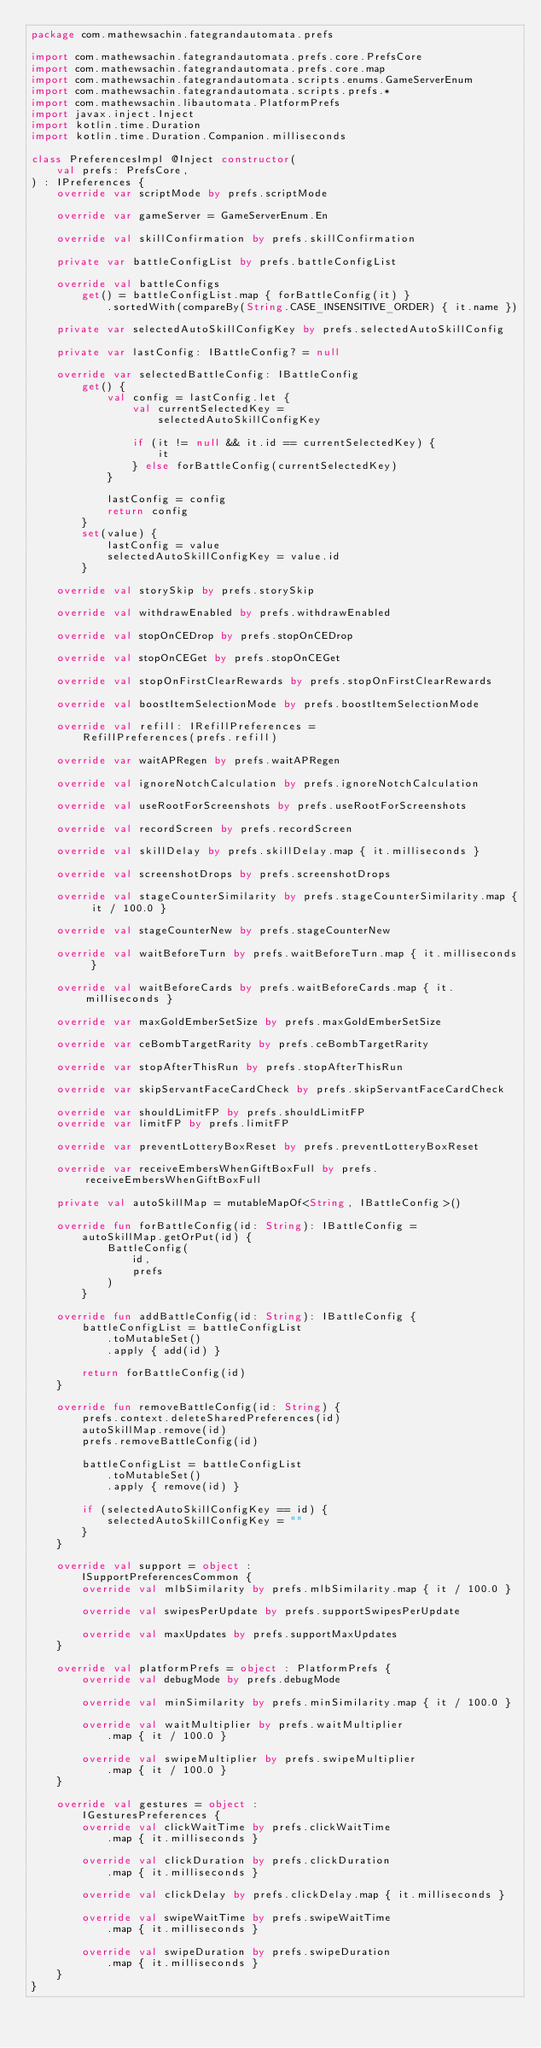Convert code to text. <code><loc_0><loc_0><loc_500><loc_500><_Kotlin_>package com.mathewsachin.fategrandautomata.prefs

import com.mathewsachin.fategrandautomata.prefs.core.PrefsCore
import com.mathewsachin.fategrandautomata.prefs.core.map
import com.mathewsachin.fategrandautomata.scripts.enums.GameServerEnum
import com.mathewsachin.fategrandautomata.scripts.prefs.*
import com.mathewsachin.libautomata.PlatformPrefs
import javax.inject.Inject
import kotlin.time.Duration
import kotlin.time.Duration.Companion.milliseconds

class PreferencesImpl @Inject constructor(
    val prefs: PrefsCore,
) : IPreferences {
    override var scriptMode by prefs.scriptMode

    override var gameServer = GameServerEnum.En

    override val skillConfirmation by prefs.skillConfirmation

    private var battleConfigList by prefs.battleConfigList

    override val battleConfigs
        get() = battleConfigList.map { forBattleConfig(it) }
            .sortedWith(compareBy(String.CASE_INSENSITIVE_ORDER) { it.name })

    private var selectedAutoSkillConfigKey by prefs.selectedAutoSkillConfig

    private var lastConfig: IBattleConfig? = null

    override var selectedBattleConfig: IBattleConfig
        get() {
            val config = lastConfig.let {
                val currentSelectedKey =
                    selectedAutoSkillConfigKey

                if (it != null && it.id == currentSelectedKey) {
                    it
                } else forBattleConfig(currentSelectedKey)
            }

            lastConfig = config
            return config
        }
        set(value) {
            lastConfig = value
            selectedAutoSkillConfigKey = value.id
        }

    override val storySkip by prefs.storySkip

    override val withdrawEnabled by prefs.withdrawEnabled

    override val stopOnCEDrop by prefs.stopOnCEDrop

    override val stopOnCEGet by prefs.stopOnCEGet

    override val stopOnFirstClearRewards by prefs.stopOnFirstClearRewards

    override val boostItemSelectionMode by prefs.boostItemSelectionMode

    override val refill: IRefillPreferences =
        RefillPreferences(prefs.refill)

    override var waitAPRegen by prefs.waitAPRegen

    override val ignoreNotchCalculation by prefs.ignoreNotchCalculation

    override val useRootForScreenshots by prefs.useRootForScreenshots

    override val recordScreen by prefs.recordScreen

    override val skillDelay by prefs.skillDelay.map { it.milliseconds }

    override val screenshotDrops by prefs.screenshotDrops

    override val stageCounterSimilarity by prefs.stageCounterSimilarity.map { it / 100.0 }

    override val stageCounterNew by prefs.stageCounterNew

    override val waitBeforeTurn by prefs.waitBeforeTurn.map { it.milliseconds }

    override val waitBeforeCards by prefs.waitBeforeCards.map { it.milliseconds }

    override var maxGoldEmberSetSize by prefs.maxGoldEmberSetSize

    override var ceBombTargetRarity by prefs.ceBombTargetRarity

    override var stopAfterThisRun by prefs.stopAfterThisRun

    override var skipServantFaceCardCheck by prefs.skipServantFaceCardCheck

    override var shouldLimitFP by prefs.shouldLimitFP
    override var limitFP by prefs.limitFP

    override var preventLotteryBoxReset by prefs.preventLotteryBoxReset

    override var receiveEmbersWhenGiftBoxFull by prefs.receiveEmbersWhenGiftBoxFull

    private val autoSkillMap = mutableMapOf<String, IBattleConfig>()

    override fun forBattleConfig(id: String): IBattleConfig =
        autoSkillMap.getOrPut(id) {
            BattleConfig(
                id,
                prefs
            )
        }

    override fun addBattleConfig(id: String): IBattleConfig {
        battleConfigList = battleConfigList
            .toMutableSet()
            .apply { add(id) }

        return forBattleConfig(id)
    }

    override fun removeBattleConfig(id: String) {
        prefs.context.deleteSharedPreferences(id)
        autoSkillMap.remove(id)
        prefs.removeBattleConfig(id)

        battleConfigList = battleConfigList
            .toMutableSet()
            .apply { remove(id) }

        if (selectedAutoSkillConfigKey == id) {
            selectedAutoSkillConfigKey = ""
        }
    }

    override val support = object :
        ISupportPreferencesCommon {
        override val mlbSimilarity by prefs.mlbSimilarity.map { it / 100.0 }

        override val swipesPerUpdate by prefs.supportSwipesPerUpdate

        override val maxUpdates by prefs.supportMaxUpdates
    }

    override val platformPrefs = object : PlatformPrefs {
        override val debugMode by prefs.debugMode

        override val minSimilarity by prefs.minSimilarity.map { it / 100.0 }

        override val waitMultiplier by prefs.waitMultiplier
            .map { it / 100.0 }

        override val swipeMultiplier by prefs.swipeMultiplier
            .map { it / 100.0 }
    }

    override val gestures = object :
        IGesturesPreferences {
        override val clickWaitTime by prefs.clickWaitTime
            .map { it.milliseconds }

        override val clickDuration by prefs.clickDuration
            .map { it.milliseconds }

        override val clickDelay by prefs.clickDelay.map { it.milliseconds }

        override val swipeWaitTime by prefs.swipeWaitTime
            .map { it.milliseconds }

        override val swipeDuration by prefs.swipeDuration
            .map { it.milliseconds }
    }
}</code> 